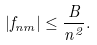<formula> <loc_0><loc_0><loc_500><loc_500>| f _ { n m } | \leq \frac { B } { n ^ { 2 } } .</formula> 